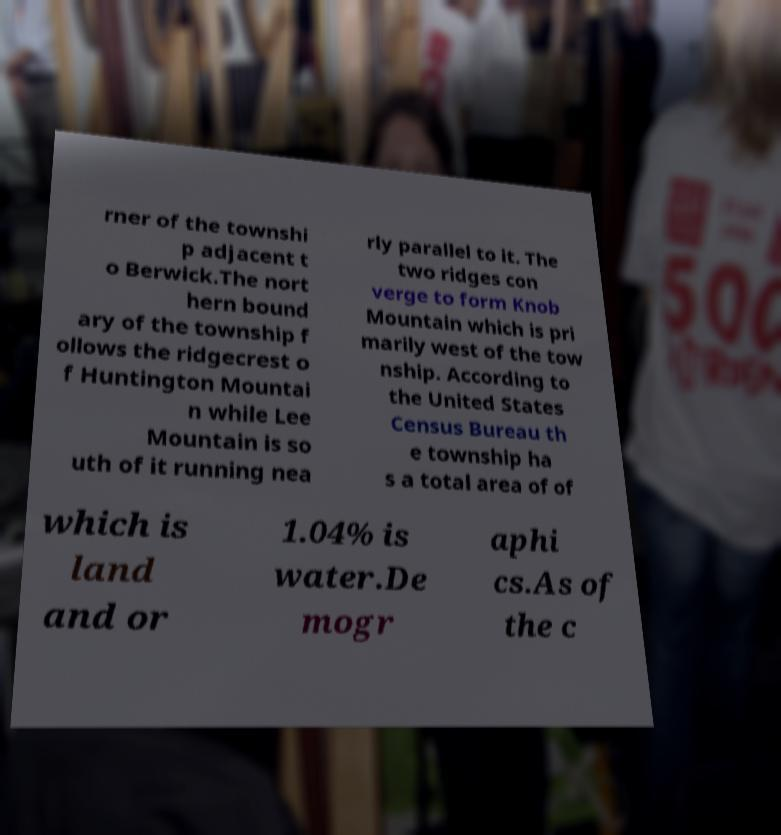There's text embedded in this image that I need extracted. Can you transcribe it verbatim? rner of the townshi p adjacent t o Berwick.The nort hern bound ary of the township f ollows the ridgecrest o f Huntington Mountai n while Lee Mountain is so uth of it running nea rly parallel to it. The two ridges con verge to form Knob Mountain which is pri marily west of the tow nship. According to the United States Census Bureau th e township ha s a total area of of which is land and or 1.04% is water.De mogr aphi cs.As of the c 